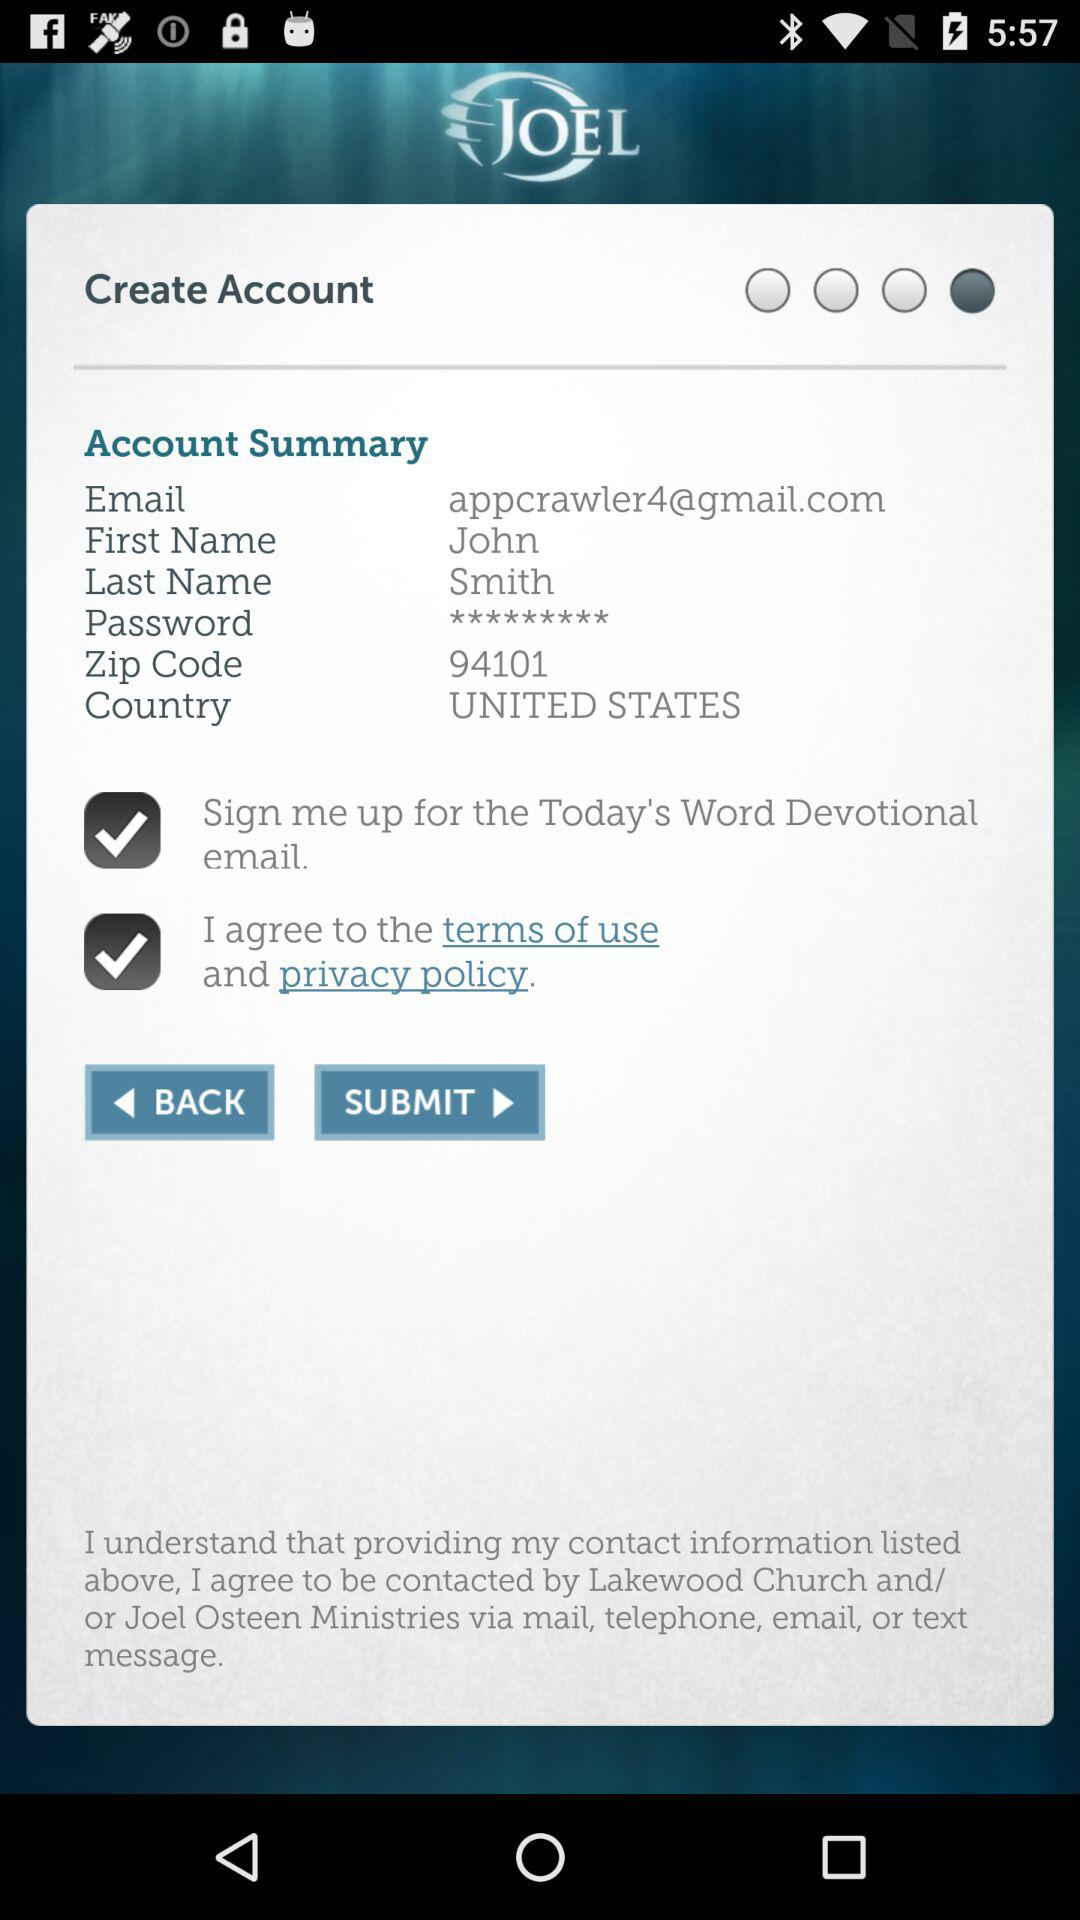What is the email address? The email address is appcrawler4@gmail.com. 